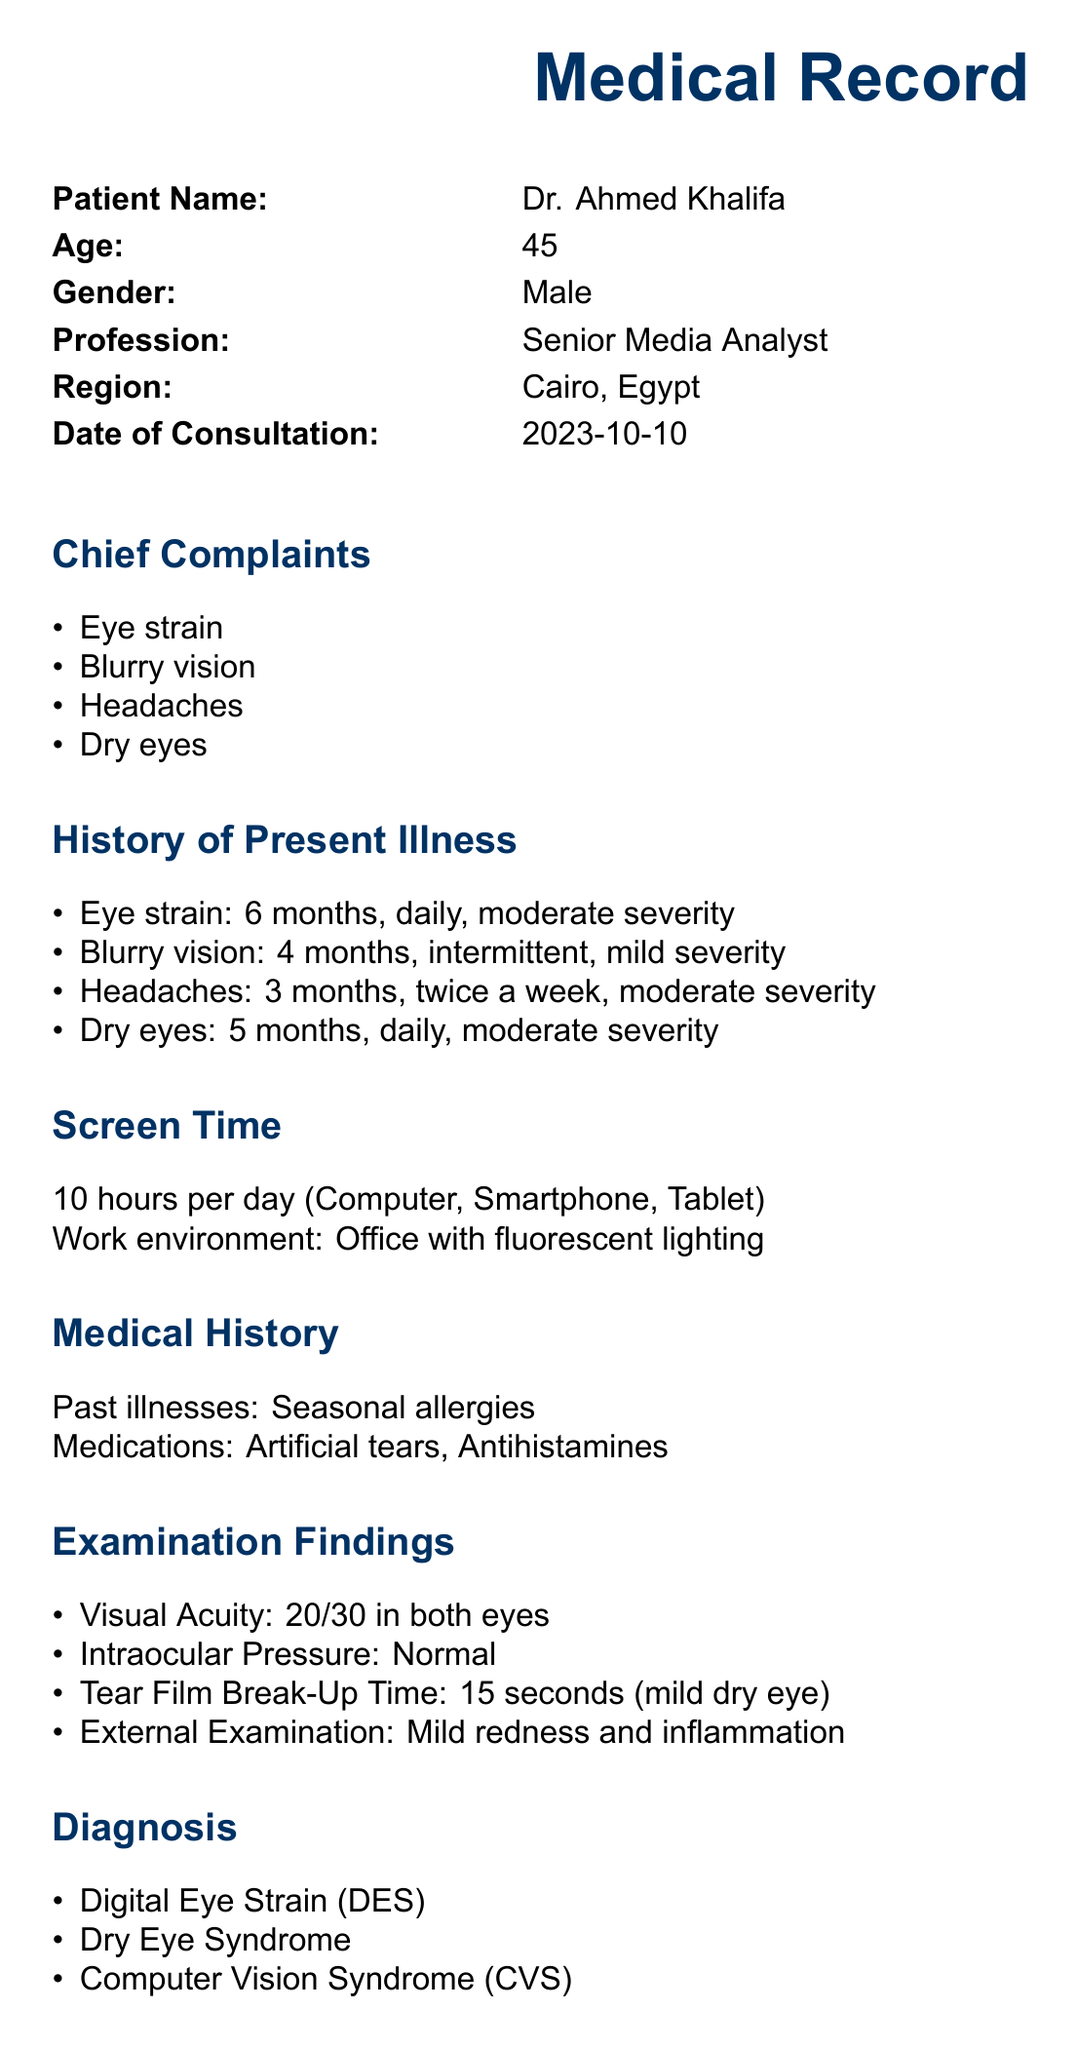What is the patient's name? The patient's name is listed in the medical record.
Answer: Dr. Ahmed Khalifa How many hours of screen time does the patient have per day? The document specifies the amount of screen time reported by the patient.
Answer: 10 hours What is one of the chief complaints mentioned? The chief complaints are clearly outlined in the document.
Answer: Eye strain What is the diagnosis provided in the document? The diagnosis section lists the medical conditions diagnosed for the patient.
Answer: Digital Eye Strain (DES) What rule is recommended in the treatment plan? The treatment plan includes specific recommendations to help alleviate symptoms.
Answer: 20-20-20 rule What type of lighting is mentioned in the patient's work environment? The work environment description indicates the type of lighting present.
Answer: Fluorescent lighting How often does the patient experience headaches? The patient’s headache frequency is detailed in the history section.
Answer: Twice a week What is the follow-up date listed in the record? The follow-up date is provided in the follow-up section of the document.
Answer: 2023-11-10 What is the visual acuity recorded for the patient? The examination findings include the visual acuity measurement.
Answer: 20/30 in both eyes 